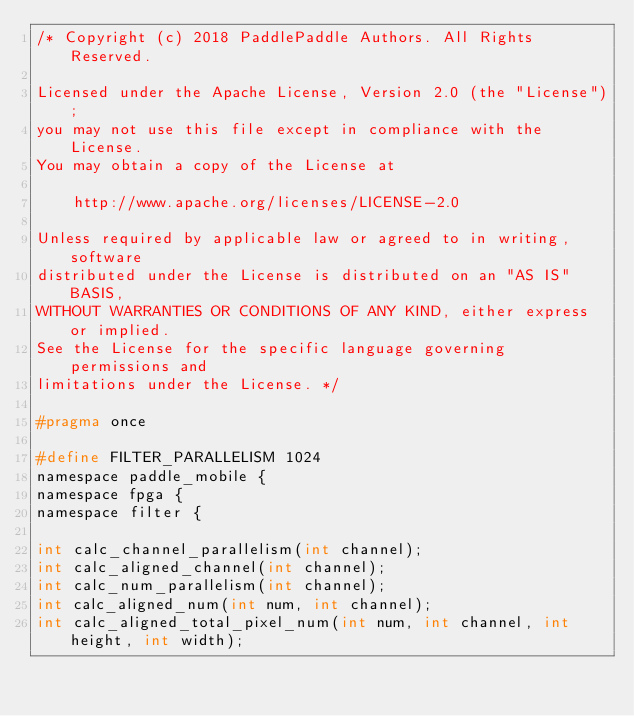Convert code to text. <code><loc_0><loc_0><loc_500><loc_500><_C_>/* Copyright (c) 2018 PaddlePaddle Authors. All Rights Reserved.

Licensed under the Apache License, Version 2.0 (the "License");
you may not use this file except in compliance with the License.
You may obtain a copy of the License at

    http://www.apache.org/licenses/LICENSE-2.0

Unless required by applicable law or agreed to in writing, software
distributed under the License is distributed on an "AS IS" BASIS,
WITHOUT WARRANTIES OR CONDITIONS OF ANY KIND, either express or implied.
See the License for the specific language governing permissions and
limitations under the License. */

#pragma once

#define FILTER_PARALLELISM 1024
namespace paddle_mobile {
namespace fpga {
namespace filter {

int calc_channel_parallelism(int channel);
int calc_aligned_channel(int channel);
int calc_num_parallelism(int channel);
int calc_aligned_num(int num, int channel);
int calc_aligned_total_pixel_num(int num, int channel, int height, int width);</code> 